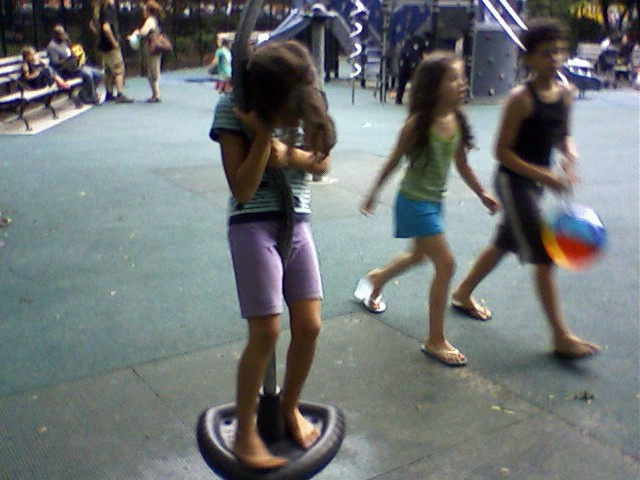Describe the objects in this image and their specific colors. I can see people in black, gray, and maroon tones, people in black, gray, and darkgray tones, people in black, gray, and maroon tones, sports ball in black, maroon, lavender, gray, and blue tones, and people in black, gray, and maroon tones in this image. 